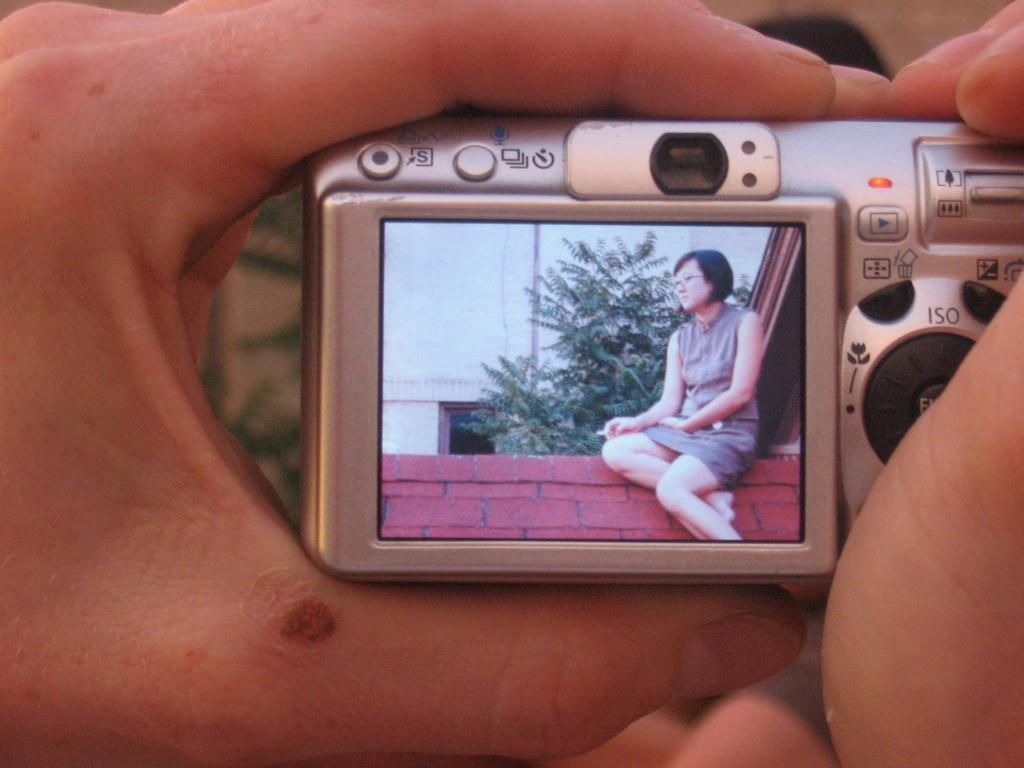<image>
Describe the image concisely. a lady is on a digital camera screen, and the hands holding it is covering the ENTER button 